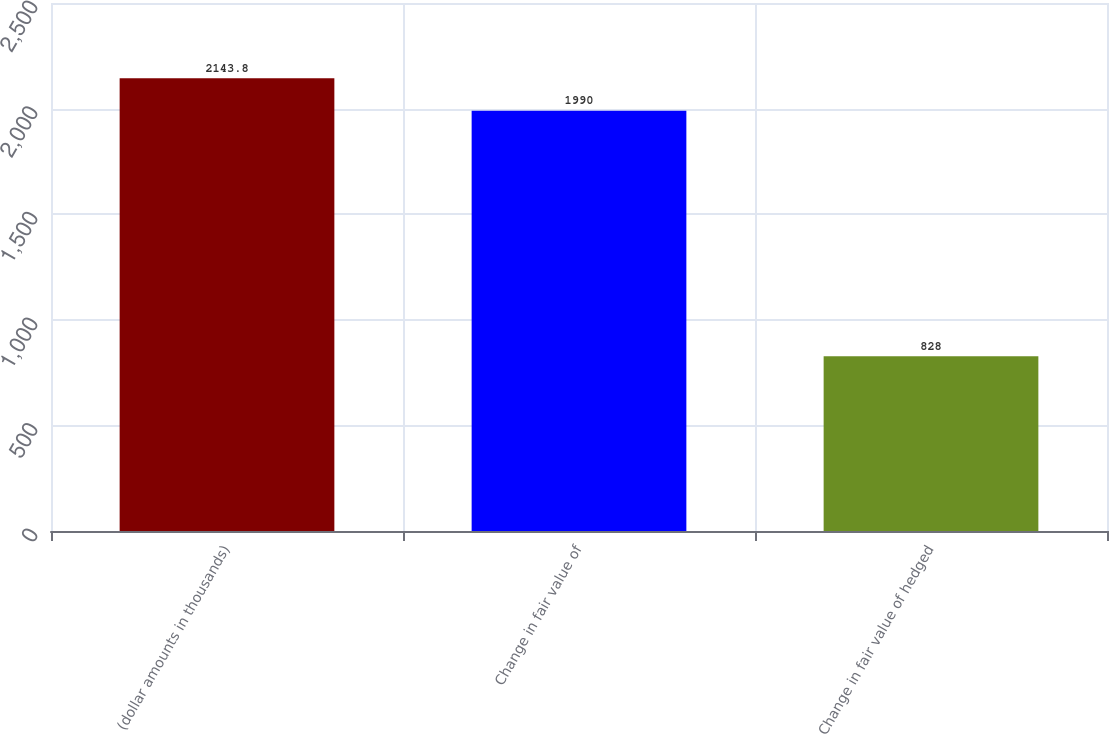Convert chart. <chart><loc_0><loc_0><loc_500><loc_500><bar_chart><fcel>(dollar amounts in thousands)<fcel>Change in fair value of<fcel>Change in fair value of hedged<nl><fcel>2143.8<fcel>1990<fcel>828<nl></chart> 